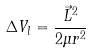<formula> <loc_0><loc_0><loc_500><loc_500>\Delta V _ { l } = \frac { \vec { L } ^ { 2 } } { 2 \mu r ^ { 2 } }</formula> 